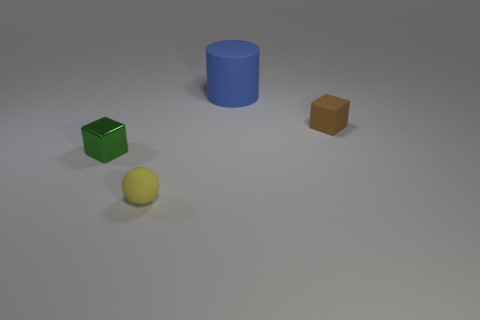Add 3 large purple cubes. How many objects exist? 7 Subtract all spheres. How many objects are left? 3 Subtract all brown blocks. How many blocks are left? 1 Add 3 metal objects. How many metal objects are left? 4 Add 2 brown metallic spheres. How many brown metallic spheres exist? 2 Subtract 1 yellow spheres. How many objects are left? 3 Subtract 1 cylinders. How many cylinders are left? 0 Subtract all blue spheres. Subtract all brown blocks. How many spheres are left? 1 Subtract all cyan cylinders. How many green blocks are left? 1 Subtract all large blue cubes. Subtract all tiny objects. How many objects are left? 1 